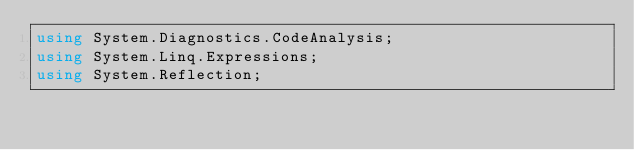<code> <loc_0><loc_0><loc_500><loc_500><_C#_>using System.Diagnostics.CodeAnalysis;
using System.Linq.Expressions;
using System.Reflection;</code> 